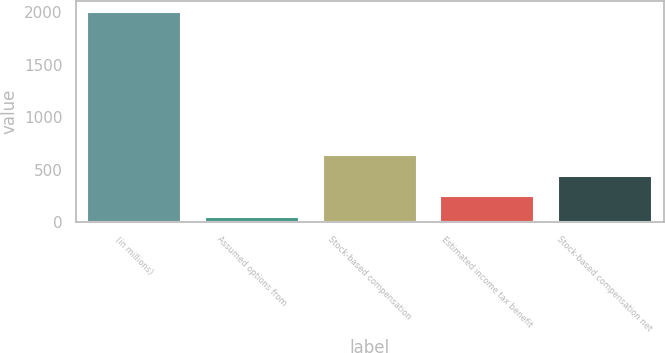<chart> <loc_0><loc_0><loc_500><loc_500><bar_chart><fcel>(in millions)<fcel>Assumed options from<fcel>Stock-based compensation<fcel>Estimated income tax benefit<fcel>Stock-based compensation net<nl><fcel>2007<fcel>49<fcel>636.4<fcel>244.8<fcel>440.6<nl></chart> 